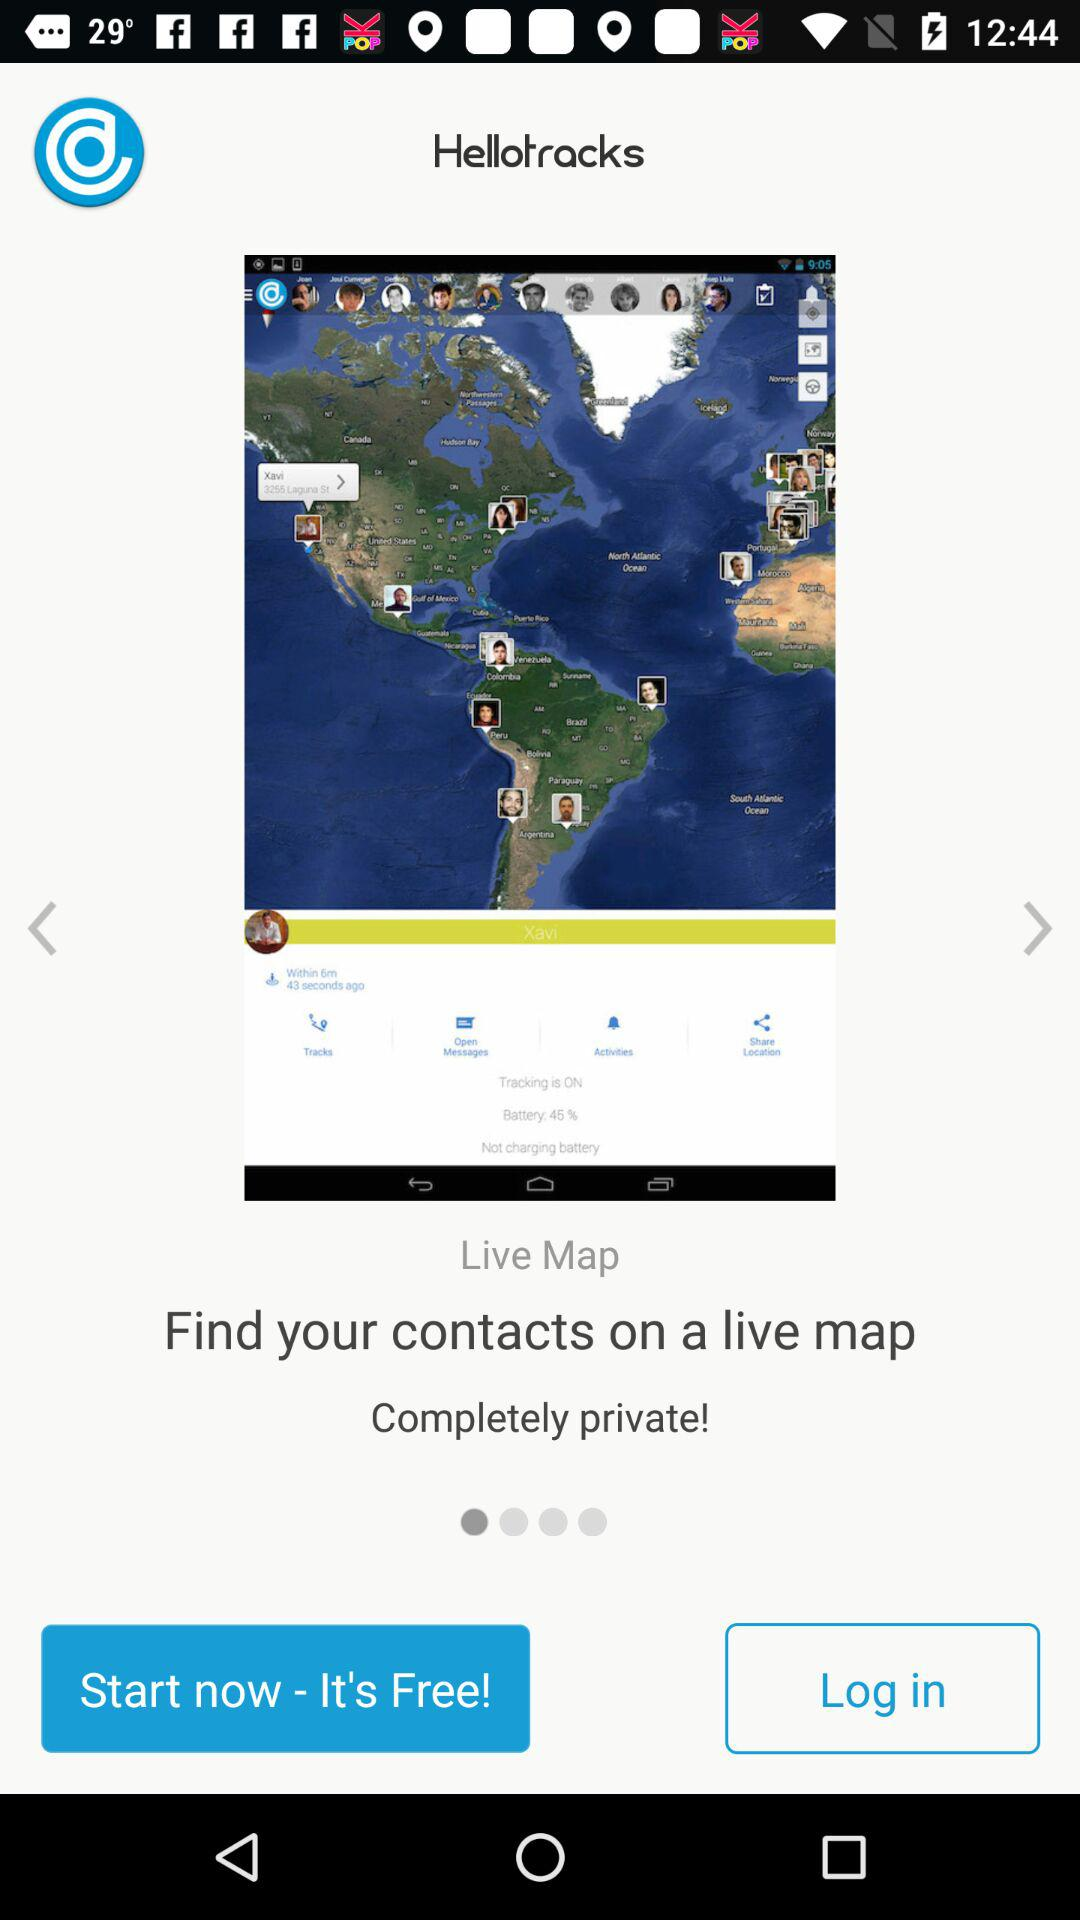What is the application name? The application name is "Hellotracks". 